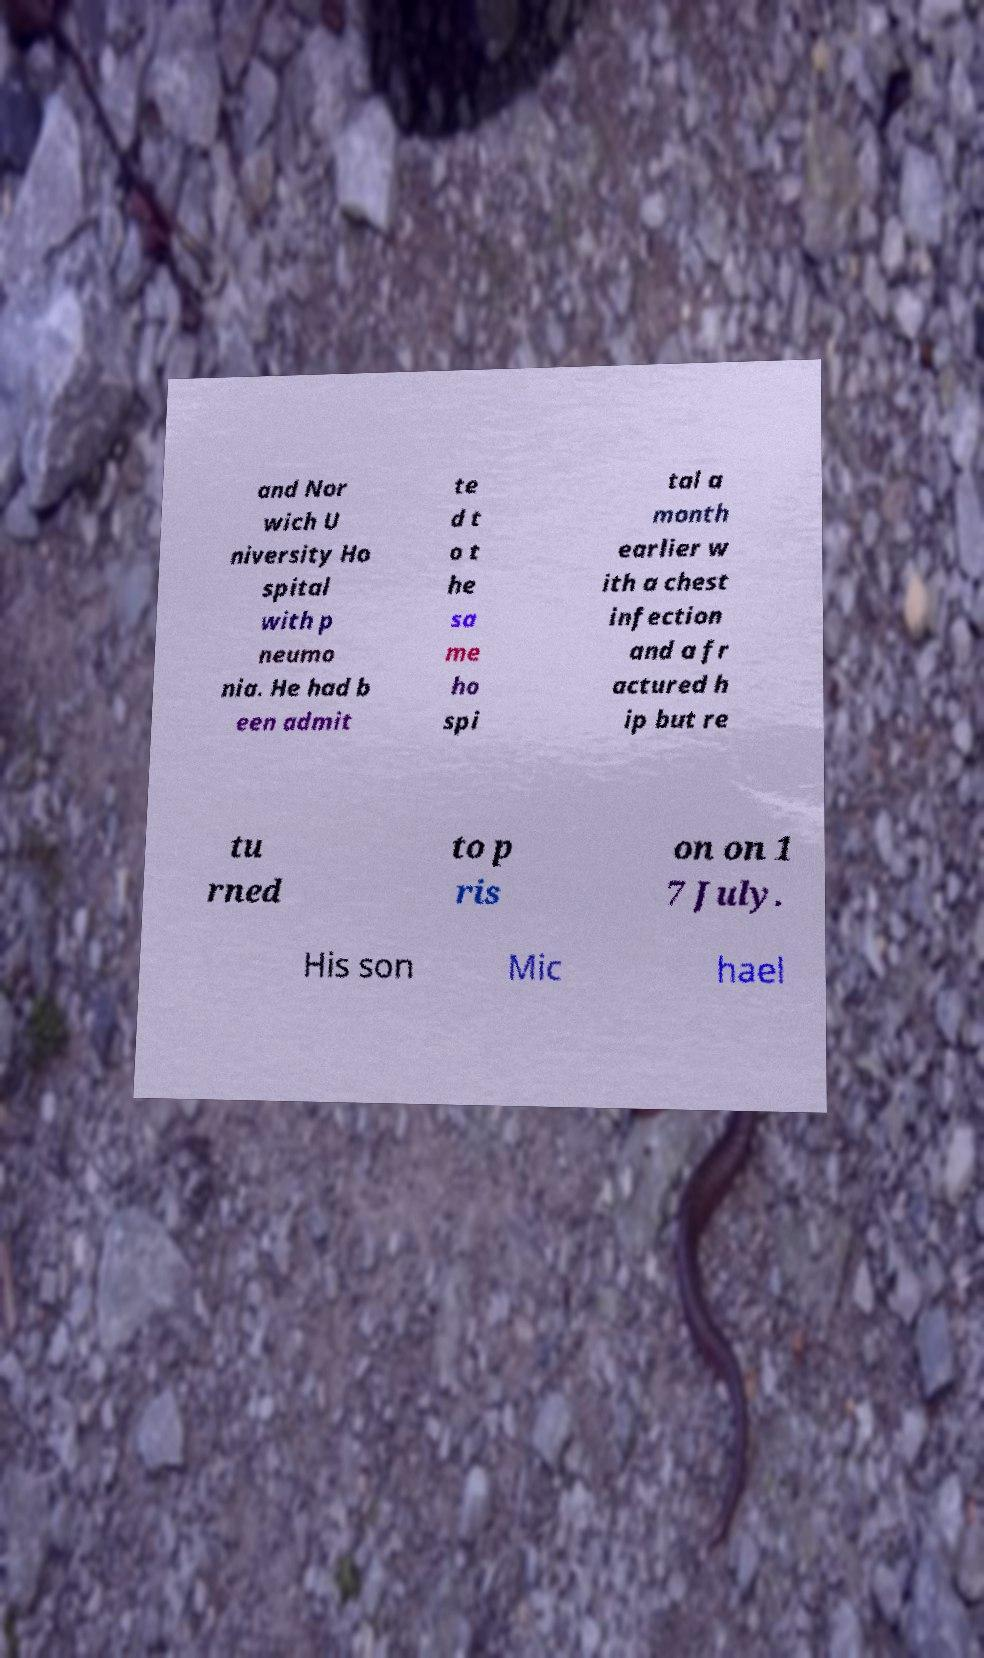I need the written content from this picture converted into text. Can you do that? and Nor wich U niversity Ho spital with p neumo nia. He had b een admit te d t o t he sa me ho spi tal a month earlier w ith a chest infection and a fr actured h ip but re tu rned to p ris on on 1 7 July. His son Mic hael 